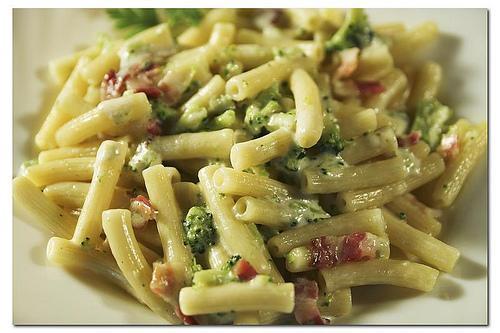How many plates are there?
Give a very brief answer. 1. How many of the ingredients shown are green?
Give a very brief answer. 1. 